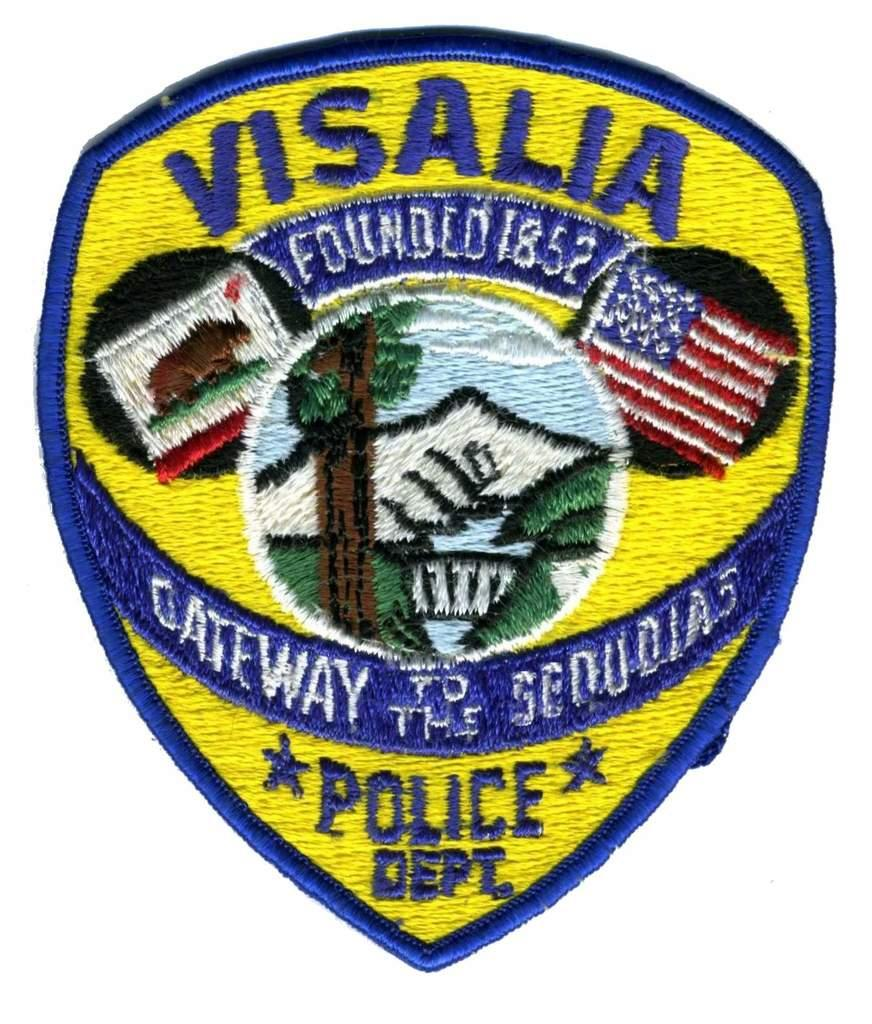What is the main subject of the image? There is a shield in the center of the image. What type of brush is being used to paint the stars in the image? There are no stars or brushes present in the image; it only features a shield. 